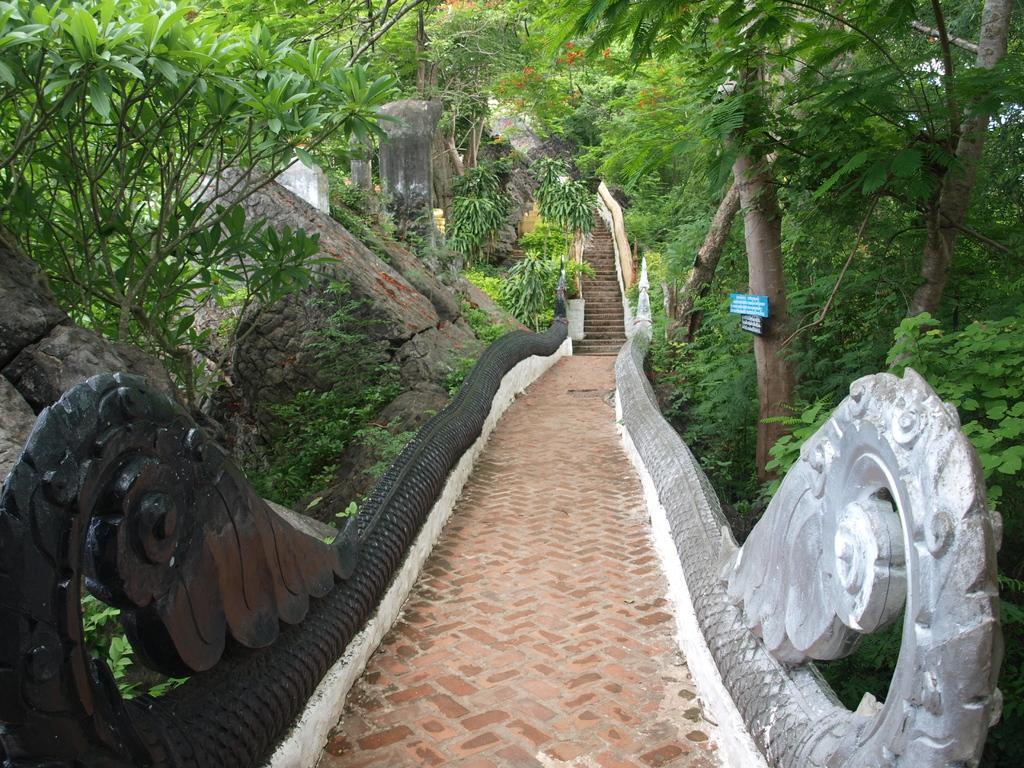Can you describe this image briefly? In this image we can see few stairs, railing, few trees and a tree with boards on the right side, few trees and rocks on the left side. 